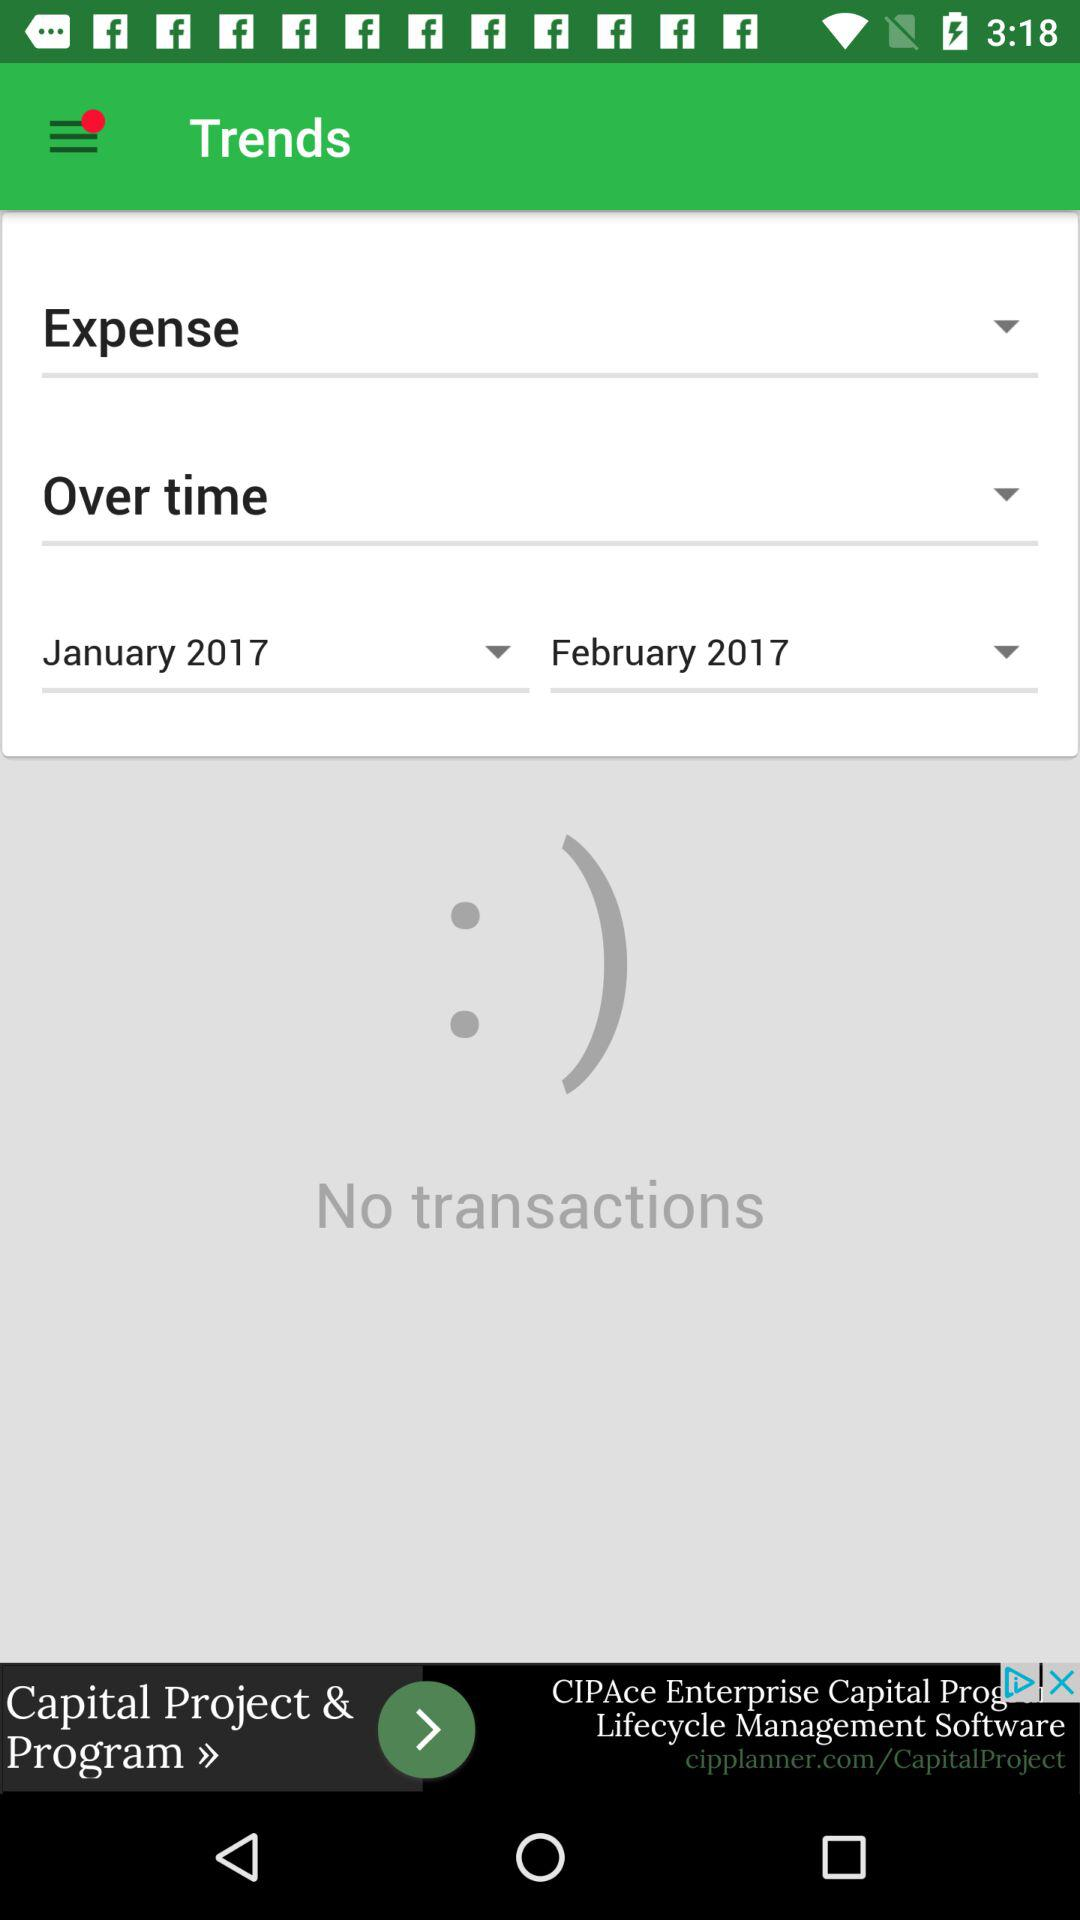How many transactions were made in February 2017?
Answer the question using a single word or phrase. 0 